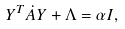Convert formula to latex. <formula><loc_0><loc_0><loc_500><loc_500>Y ^ { T } \dot { A } Y + \Lambda = \alpha I ,</formula> 